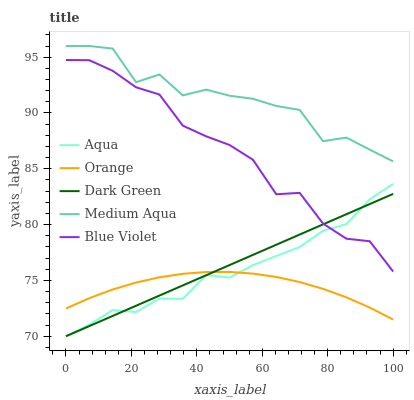Does Orange have the minimum area under the curve?
Answer yes or no. Yes. Does Medium Aqua have the maximum area under the curve?
Answer yes or no. Yes. Does Aqua have the minimum area under the curve?
Answer yes or no. No. Does Aqua have the maximum area under the curve?
Answer yes or no. No. Is Dark Green the smoothest?
Answer yes or no. Yes. Is Medium Aqua the roughest?
Answer yes or no. Yes. Is Aqua the smoothest?
Answer yes or no. No. Is Aqua the roughest?
Answer yes or no. No. Does Aqua have the lowest value?
Answer yes or no. Yes. Does Medium Aqua have the lowest value?
Answer yes or no. No. Does Medium Aqua have the highest value?
Answer yes or no. Yes. Does Aqua have the highest value?
Answer yes or no. No. Is Orange less than Blue Violet?
Answer yes or no. Yes. Is Medium Aqua greater than Dark Green?
Answer yes or no. Yes. Does Orange intersect Aqua?
Answer yes or no. Yes. Is Orange less than Aqua?
Answer yes or no. No. Is Orange greater than Aqua?
Answer yes or no. No. Does Orange intersect Blue Violet?
Answer yes or no. No. 